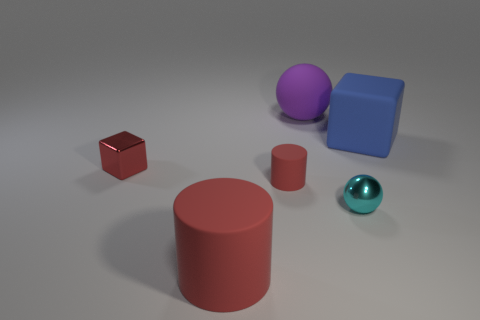Are there more large objects in front of the big ball than small red blocks that are on the right side of the cyan metal thing?
Give a very brief answer. Yes. There is a shiny object that is the same size as the cyan ball; what is its color?
Provide a short and direct response. Red. Are there any large cylinders of the same color as the tiny rubber cylinder?
Provide a succinct answer. Yes. Do the large object that is in front of the red block and the cylinder behind the small cyan metal ball have the same color?
Give a very brief answer. Yes. What is the material of the block that is left of the big blue rubber cube?
Make the answer very short. Metal. What color is the ball that is the same material as the blue cube?
Ensure brevity in your answer.  Purple. How many gray metallic cubes have the same size as the red shiny block?
Offer a terse response. 0. Does the block that is on the right side of the cyan ball have the same size as the red metallic thing?
Provide a succinct answer. No. There is a thing that is in front of the tiny cylinder and to the left of the metal sphere; what is its shape?
Your response must be concise. Cylinder. Are there any cubes to the right of the big red object?
Provide a succinct answer. Yes. 